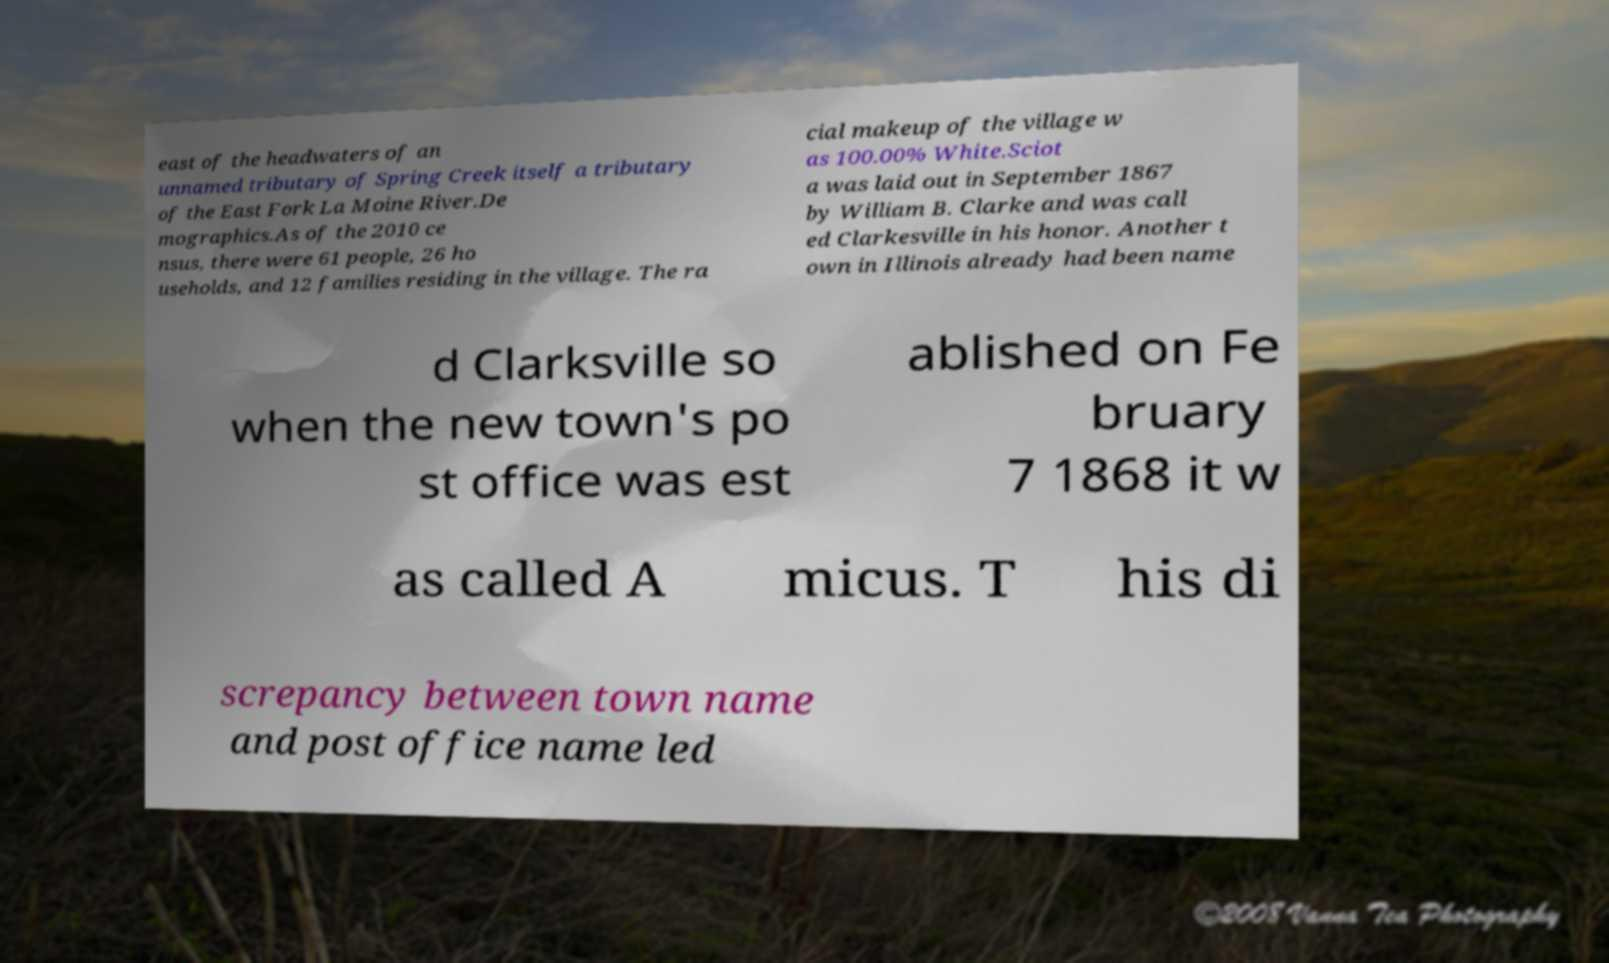Can you read and provide the text displayed in the image?This photo seems to have some interesting text. Can you extract and type it out for me? east of the headwaters of an unnamed tributary of Spring Creek itself a tributary of the East Fork La Moine River.De mographics.As of the 2010 ce nsus, there were 61 people, 26 ho useholds, and 12 families residing in the village. The ra cial makeup of the village w as 100.00% White.Sciot a was laid out in September 1867 by William B. Clarke and was call ed Clarkesville in his honor. Another t own in Illinois already had been name d Clarksville so when the new town's po st office was est ablished on Fe bruary 7 1868 it w as called A micus. T his di screpancy between town name and post office name led 